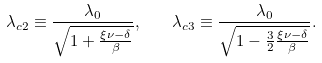<formula> <loc_0><loc_0><loc_500><loc_500>\lambda _ { c 2 } \equiv \frac { \lambda _ { 0 } } { \sqrt { 1 + \frac { \xi \nu - \delta } { \beta } } } , \quad \lambda _ { c 3 } \equiv \frac { \lambda _ { 0 } } { \sqrt { 1 - \frac { 3 } { 2 } \frac { \xi \nu - \delta } { \beta } } } .</formula> 